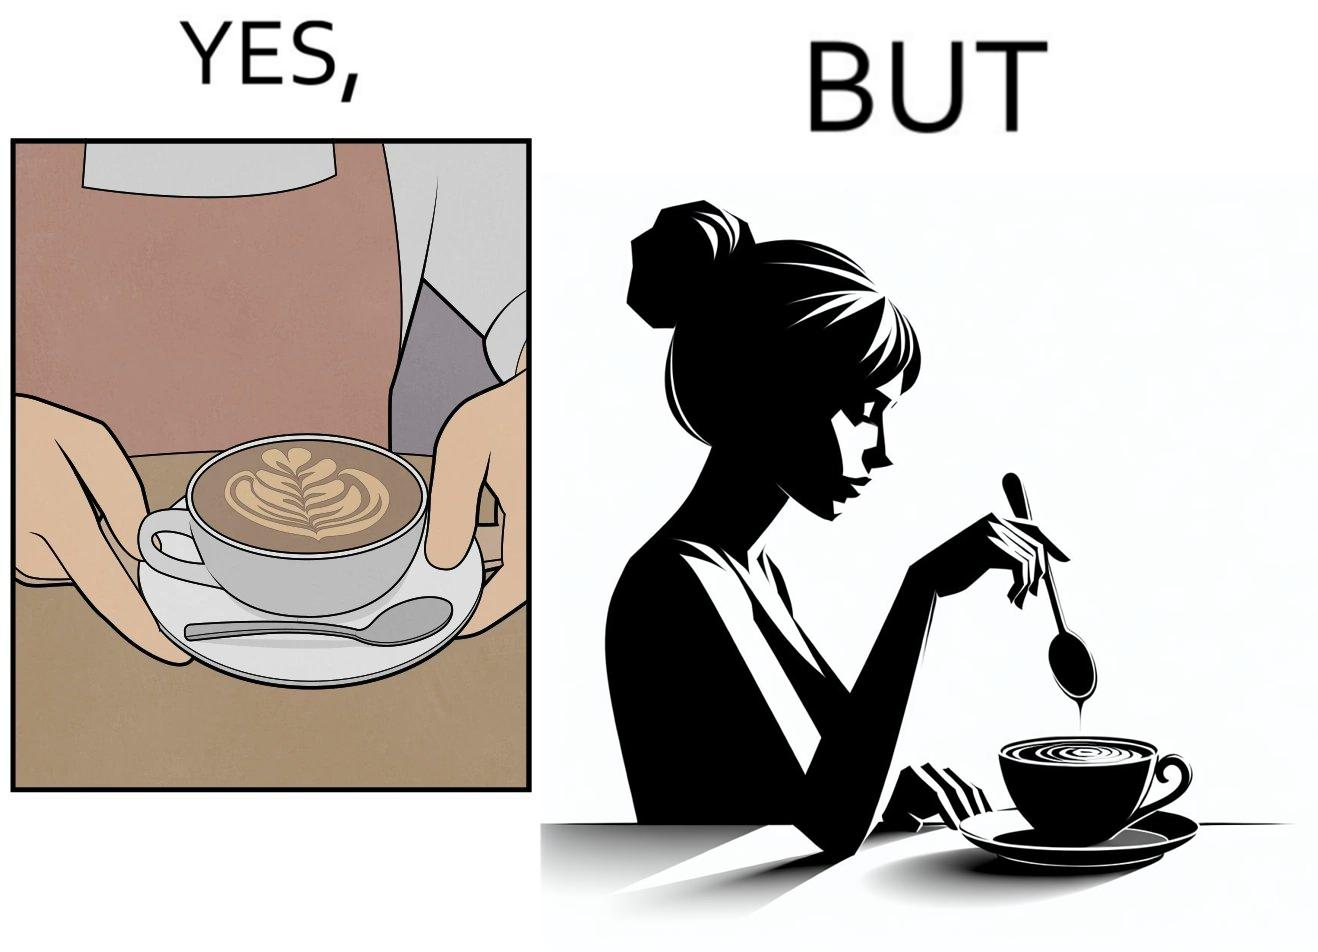Describe the satirical element in this image. The image is ironic, because even when the coffee maker create latte art to make coffee look attractive but it is there just for a short time after that it is vanished 